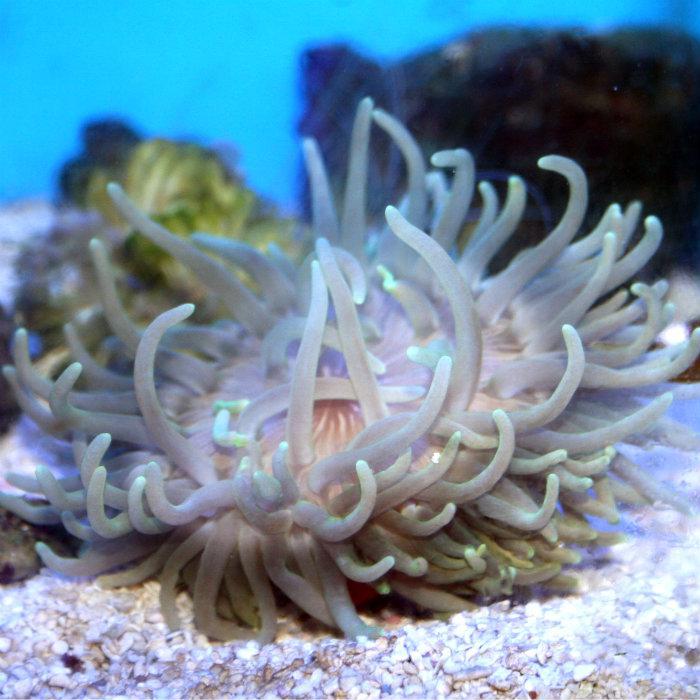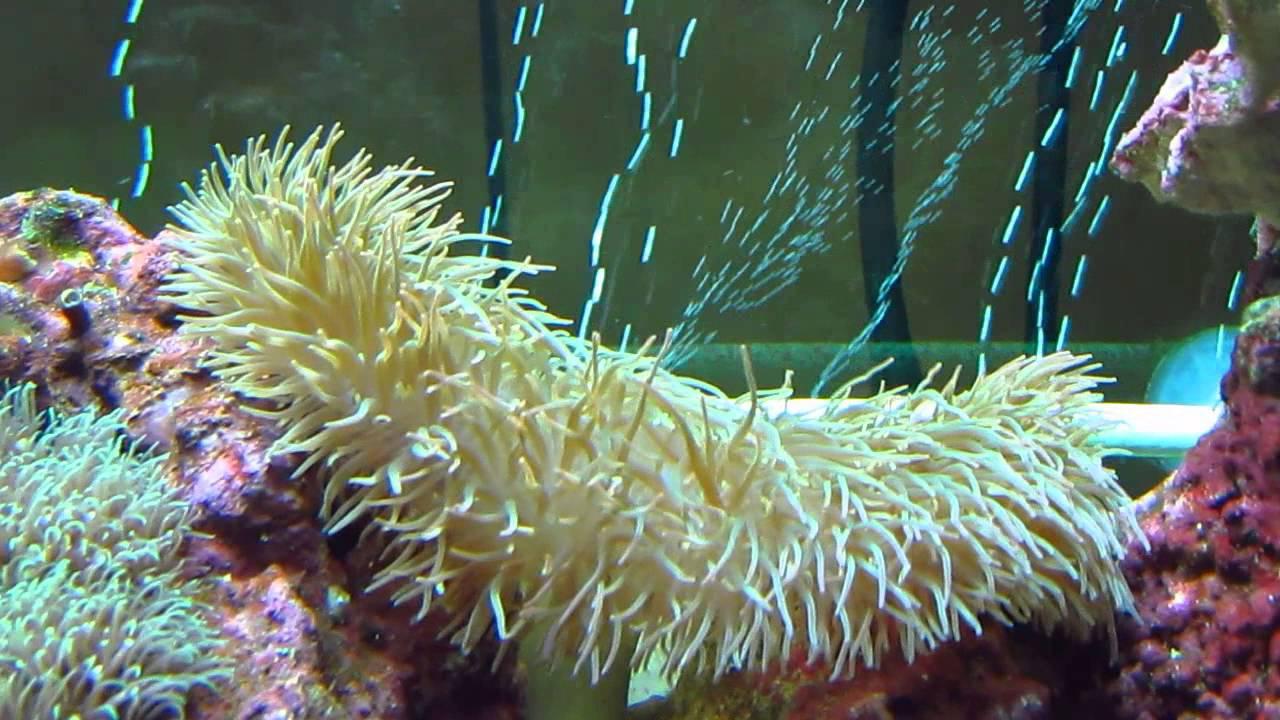The first image is the image on the left, the second image is the image on the right. Given the left and right images, does the statement "An image shows a neutral-colored anemone with sky blue background." hold true? Answer yes or no. Yes. The first image is the image on the left, the second image is the image on the right. For the images displayed, is the sentence "the anemone in one of the images is very wide" factually correct? Answer yes or no. Yes. 